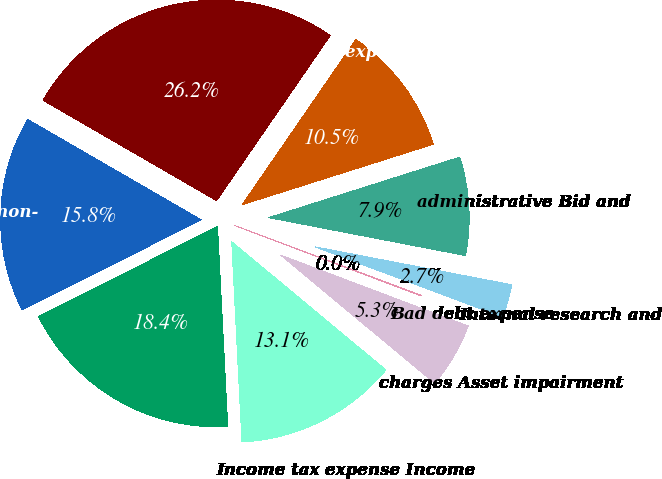Convert chart to OTSL. <chart><loc_0><loc_0><loc_500><loc_500><pie_chart><fcel>Cost of revenues Selling<fcel>expenses General and<fcel>administrative Bid and<fcel>Internal research and<fcel>Bad debt expense<fcel>charges Asset impairment<fcel>Income tax expense Income<fcel>continuing operations<fcel>attributable to non-<nl><fcel>26.25%<fcel>10.53%<fcel>7.91%<fcel>2.67%<fcel>0.05%<fcel>5.29%<fcel>13.15%<fcel>18.39%<fcel>15.77%<nl></chart> 